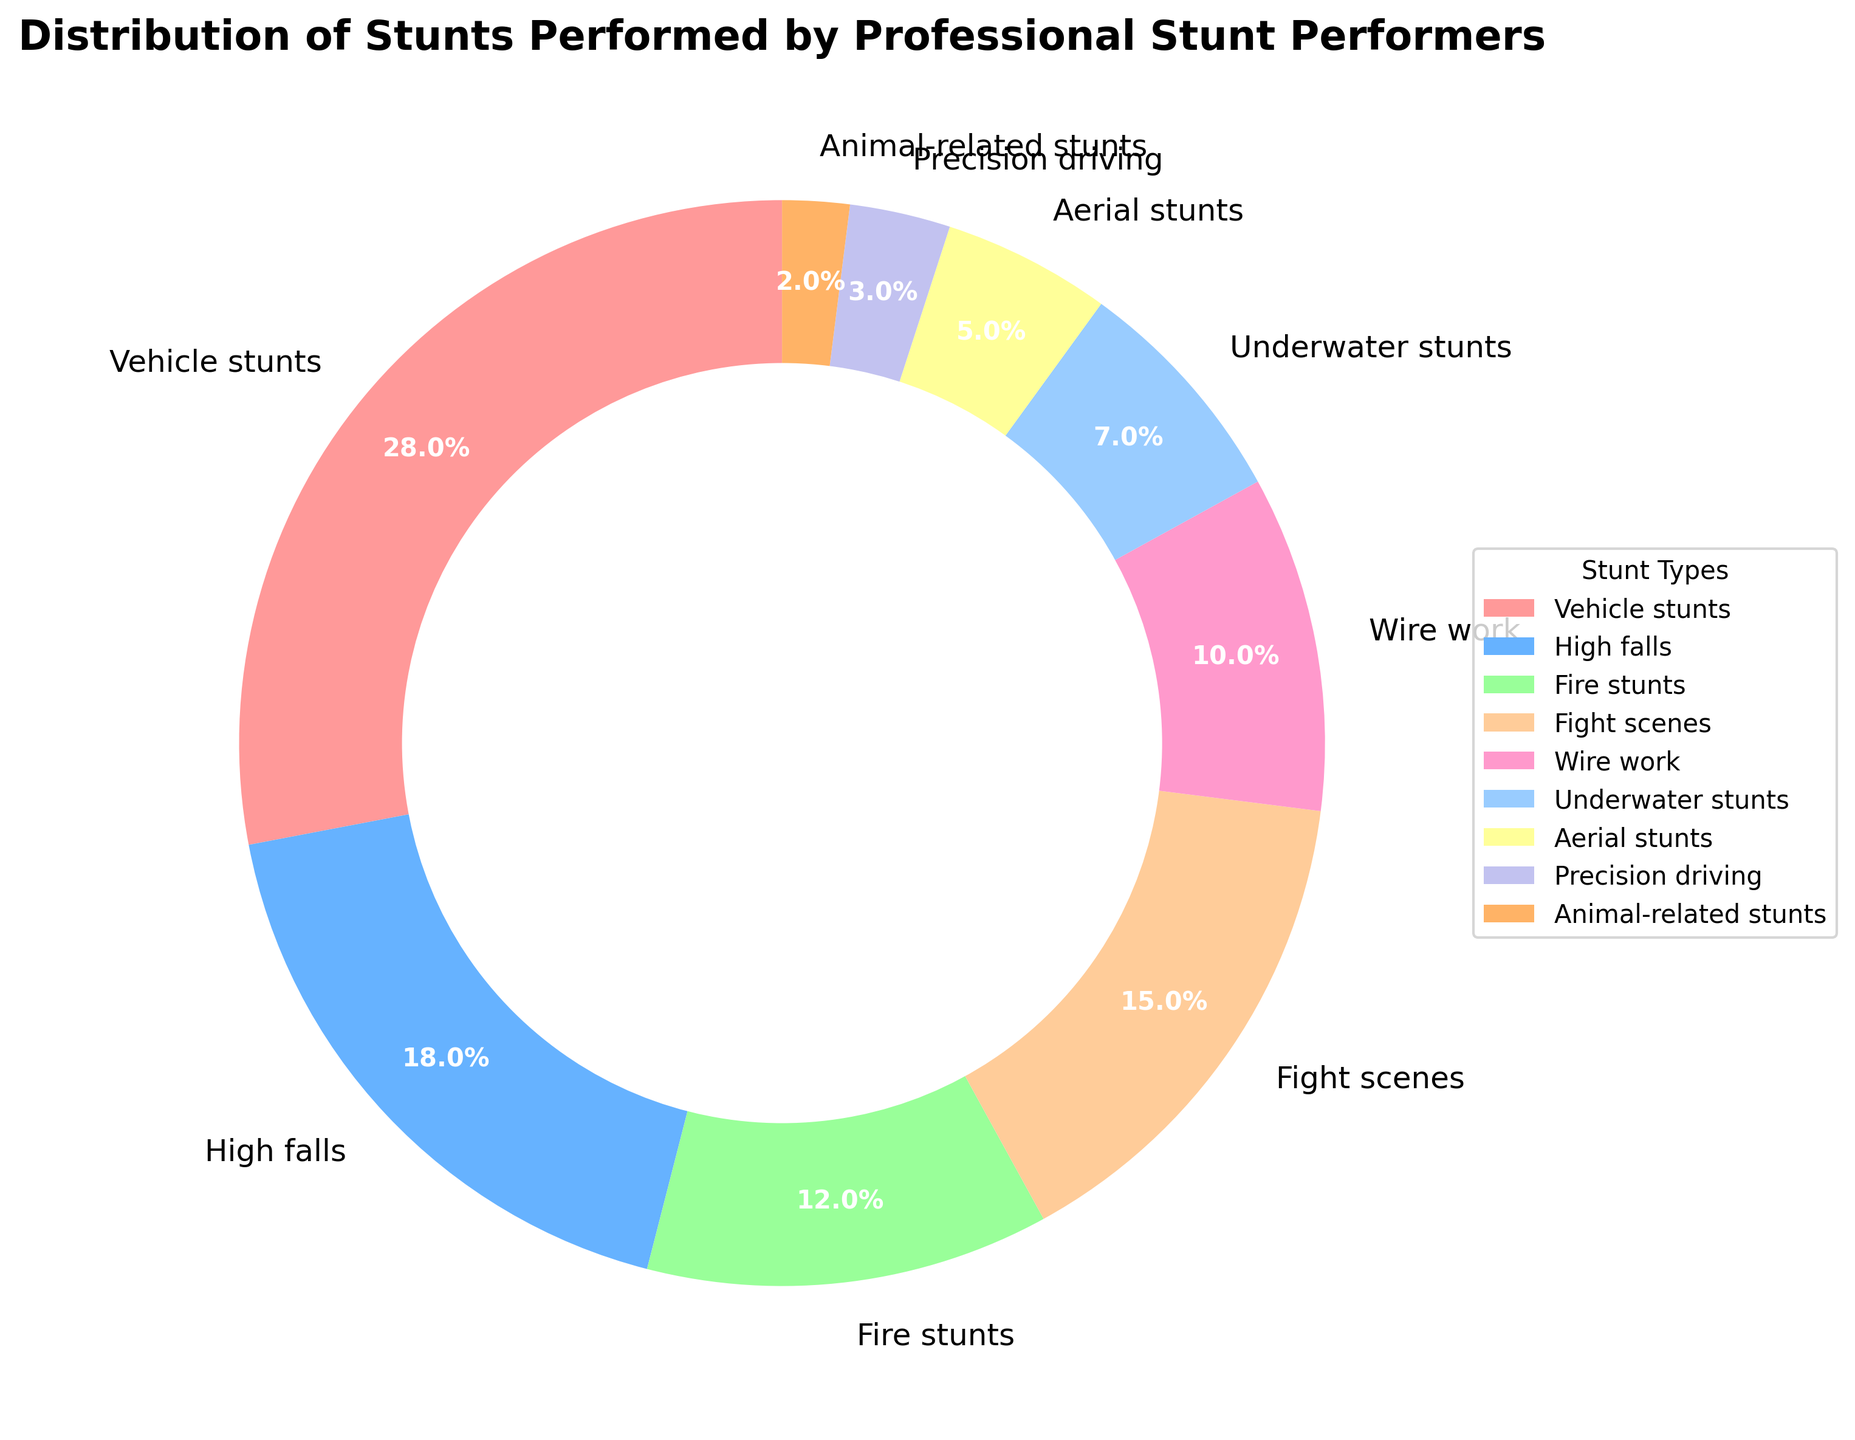Which type of stunt is performed the most? By glancing at the pie chart, the largest segment is for Vehicle stunts, taking up 28% of the chart. This means Vehicle stunts are performed the most.
Answer: Vehicle stunts Compare the percentages of High falls and Fire stunts. Which one is greater? The pie chart shows that High falls account for 18% while Fire stunts account for 12%. Since 18% is greater than 12%, High falls are more common.
Answer: High falls What is the combined percentage of Aerial stunts and Precision driving? According to the pie chart, Aerial stunts are 5% and Precision driving is 3%. Adding these together (5% + 3%) gives a combined percentage of 8%.
Answer: 8% How much more common are Vehicle stunts compared to Wire work? The chart shows Vehicle stunts at 28% and Wire work at 10%. To find out how much more common Vehicle stunts are, subtract Wire work's percentage from Vehicle stunts' (28% - 10%).
Answer: 18% What fraction of the stunts are either Animal-related or Underwater stunts? From the pie chart, Animal-related stunts are 2% and Underwater stunts are 7%. The total is 2% + 7% = 9%. To express this as a fraction of the whole 100%, it is 9/100 or 0.09.
Answer: 0.09 Is the proportion of Fight scenes greater than 10%? As depicted in the pie chart, Fight scenes account for 15% which is indeed greater than 10%.
Answer: Yes What is the color of the segment representing Fire stunts? The segment for Fire stunts is shaded in a distinct color. According to the figure setup, Fire stunts are represented in a pinkish hue.
Answer: A shade of pink Among High falls and Aerial stunts, which has a smaller percentage, and by how much? The pie chart indicates High falls are 18% while Aerial stunts are 5%. To determine which is smaller and by how much, subtract the smaller percentage from the larger (18% - 5%).
Answer: Aerial stunts, by 13% Which type of stunt is least performed? By observing the pie chart, the smallest segment corresponds to Animal-related stunts at 2%. This makes it the least performed stunt.
Answer: Animal-related stunts 